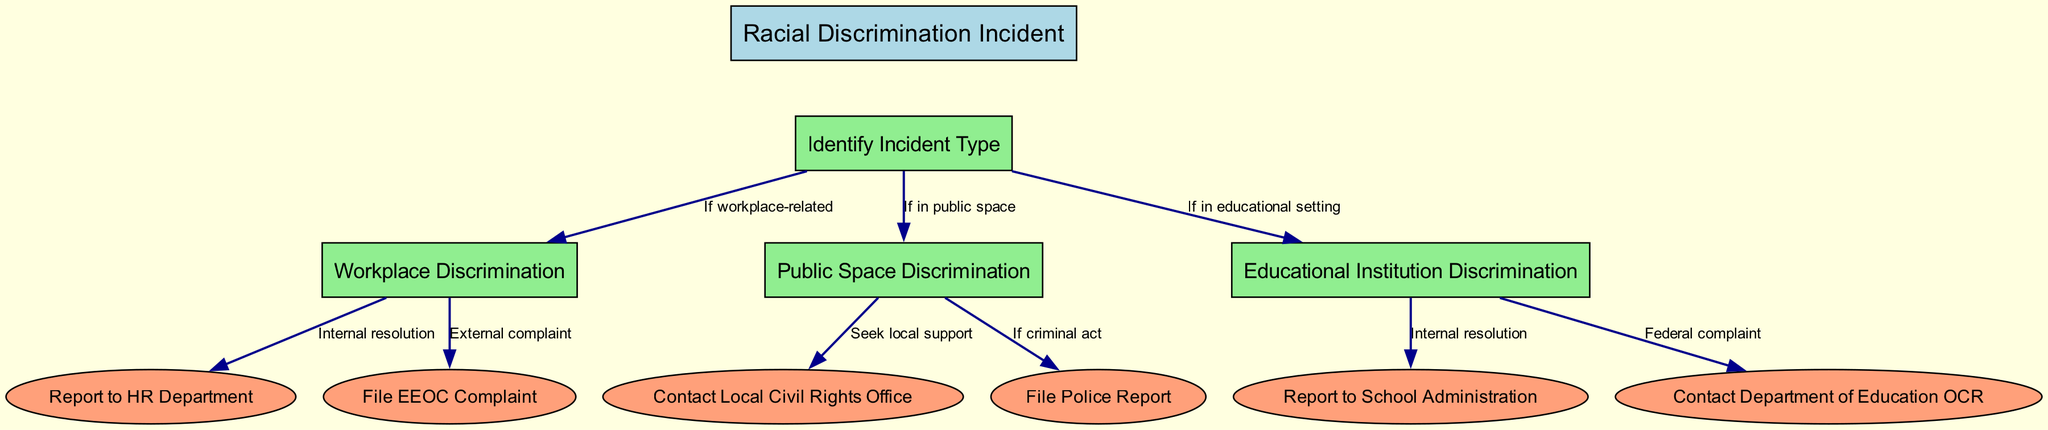What is the root node's label? The root node is labeled "Racial Discrimination Incident" as indicated at the top of the diagram.
Answer: Racial Discrimination Incident How many types of discrimination incidents are identified? The diagram identifies three types of discrimination incidents: Workplace Discrimination, Public Space Discrimination, and Educational Institution Discrimination.
Answer: Three What action follows Workplace Discrimination if seeking internal resolution? If seeking internal resolution after Workplace Discrimination, the next action is to "Report to HR Department."
Answer: Report to HR Department Which agency might you contact if the discrimination occurs in public space and is considered a criminal act? If a discrimination incident occurs in a public space and is considered a criminal act, the subsequent action is to "File Police Report."
Answer: File Police Report What is the final step if you are reporting Educational Institution Discrimination as a federal complaint? If someone is reporting Educational Institution Discrimination as a federal complaint, the final step is to "Contact Department of Education OCR."
Answer: Contact Department of Education OCR Which nodes lead from the Public Space Discrimination? The nodes that lead from Public Space Discrimination are "Contact Local Civil Rights Office" and "File Police Report."
Answer: Contact Local Civil Rights Office, File Police Report What does the edge from the root to Educational Institution Discrimination indicate? The edge from the root to Educational Institution Discrimination indicates that the path is chosen if the incident occurs in an educational setting.
Answer: If in educational setting What do the colored shapes represent in the diagram? In the diagram, the box-shaped nodes represent decision points regarding the type of incident, while the ellipse-shaped nodes indicate the final actions or resolutions related to those incidents.
Answer: Decision points and final actions 